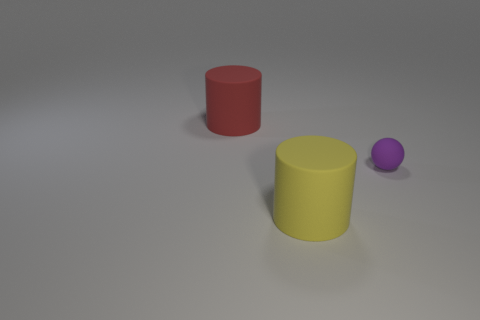Add 2 blue rubber cylinders. How many objects exist? 5 Subtract all spheres. How many objects are left? 2 Add 1 big yellow cylinders. How many big yellow cylinders exist? 2 Subtract 0 gray spheres. How many objects are left? 3 Subtract all tiny gray matte blocks. Subtract all tiny purple matte balls. How many objects are left? 2 Add 1 rubber objects. How many rubber objects are left? 4 